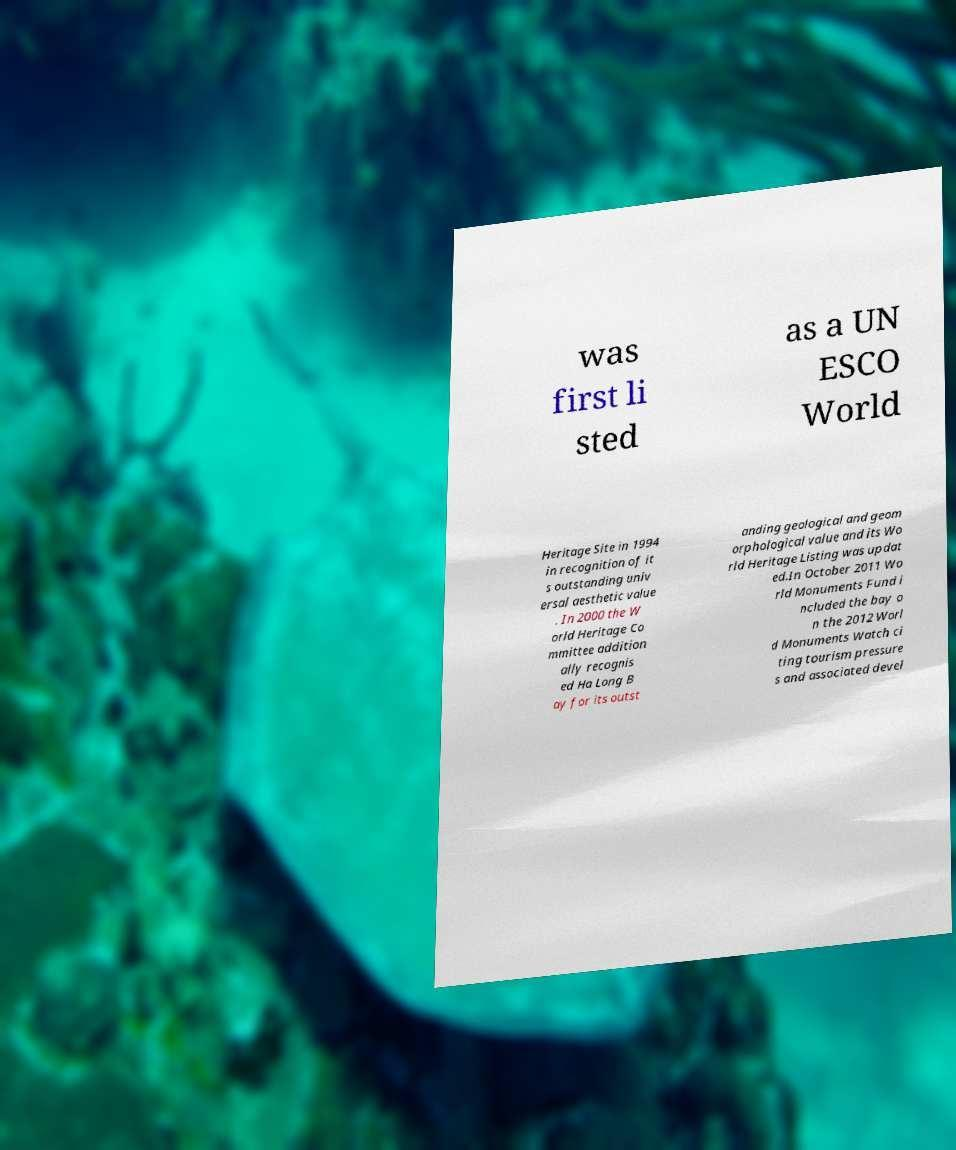Please read and relay the text visible in this image. What does it say? was first li sted as a UN ESCO World Heritage Site in 1994 in recognition of it s outstanding univ ersal aesthetic value . In 2000 the W orld Heritage Co mmittee addition ally recognis ed Ha Long B ay for its outst anding geological and geom orphological value and its Wo rld Heritage Listing was updat ed.In October 2011 Wo rld Monuments Fund i ncluded the bay o n the 2012 Worl d Monuments Watch ci ting tourism pressure s and associated devel 